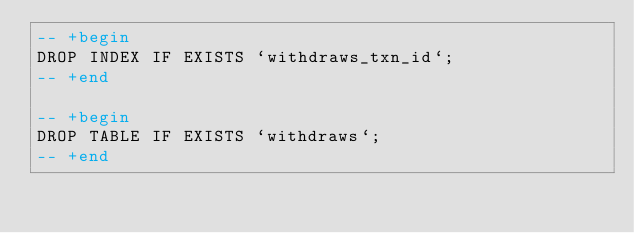Convert code to text. <code><loc_0><loc_0><loc_500><loc_500><_SQL_>-- +begin
DROP INDEX IF EXISTS `withdraws_txn_id`;
-- +end

-- +begin
DROP TABLE IF EXISTS `withdraws`;
-- +end

</code> 